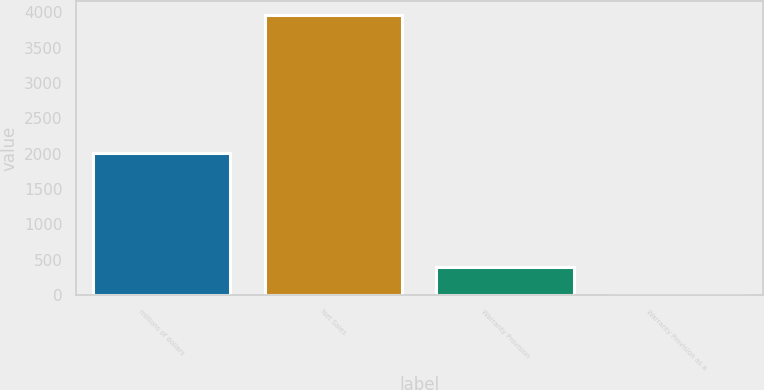Convert chart. <chart><loc_0><loc_0><loc_500><loc_500><bar_chart><fcel>millions of dollars<fcel>Net Sales<fcel>Warranty Provision<fcel>Warranty Provision as a<nl><fcel>2009<fcel>3961.8<fcel>397.26<fcel>1.2<nl></chart> 